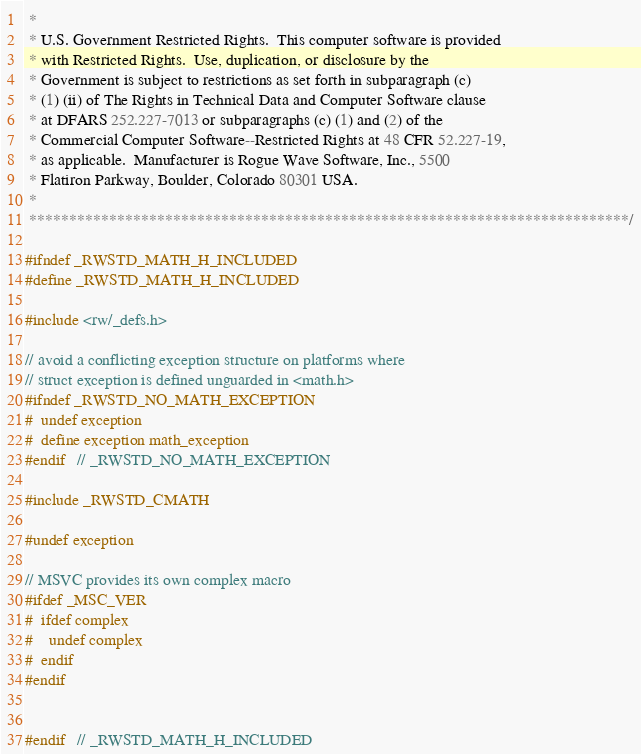<code> <loc_0><loc_0><loc_500><loc_500><_C_> *
 * U.S. Government Restricted Rights.  This computer software is provided
 * with Restricted Rights.  Use, duplication, or disclosure by the
 * Government is subject to restrictions as set forth in subparagraph (c)
 * (1) (ii) of The Rights in Technical Data and Computer Software clause
 * at DFARS 252.227-7013 or subparagraphs (c) (1) and (2) of the
 * Commercial Computer Software--Restricted Rights at 48 CFR 52.227-19,
 * as applicable.  Manufacturer is Rogue Wave Software, Inc., 5500
 * Flatiron Parkway, Boulder, Colorado 80301 USA.
 *
 ***************************************************************************/

#ifndef _RWSTD_MATH_H_INCLUDED
#define _RWSTD_MATH_H_INCLUDED

#include <rw/_defs.h>

// avoid a conflicting exception structure on platforms where
// struct exception is defined unguarded in <math.h>
#ifndef _RWSTD_NO_MATH_EXCEPTION
#  undef exception
#  define exception math_exception
#endif   // _RWSTD_NO_MATH_EXCEPTION

#include _RWSTD_CMATH

#undef exception

// MSVC provides its own complex macro
#ifdef _MSC_VER
#  ifdef complex
#    undef complex
#  endif
#endif


#endif   // _RWSTD_MATH_H_INCLUDED

</code> 